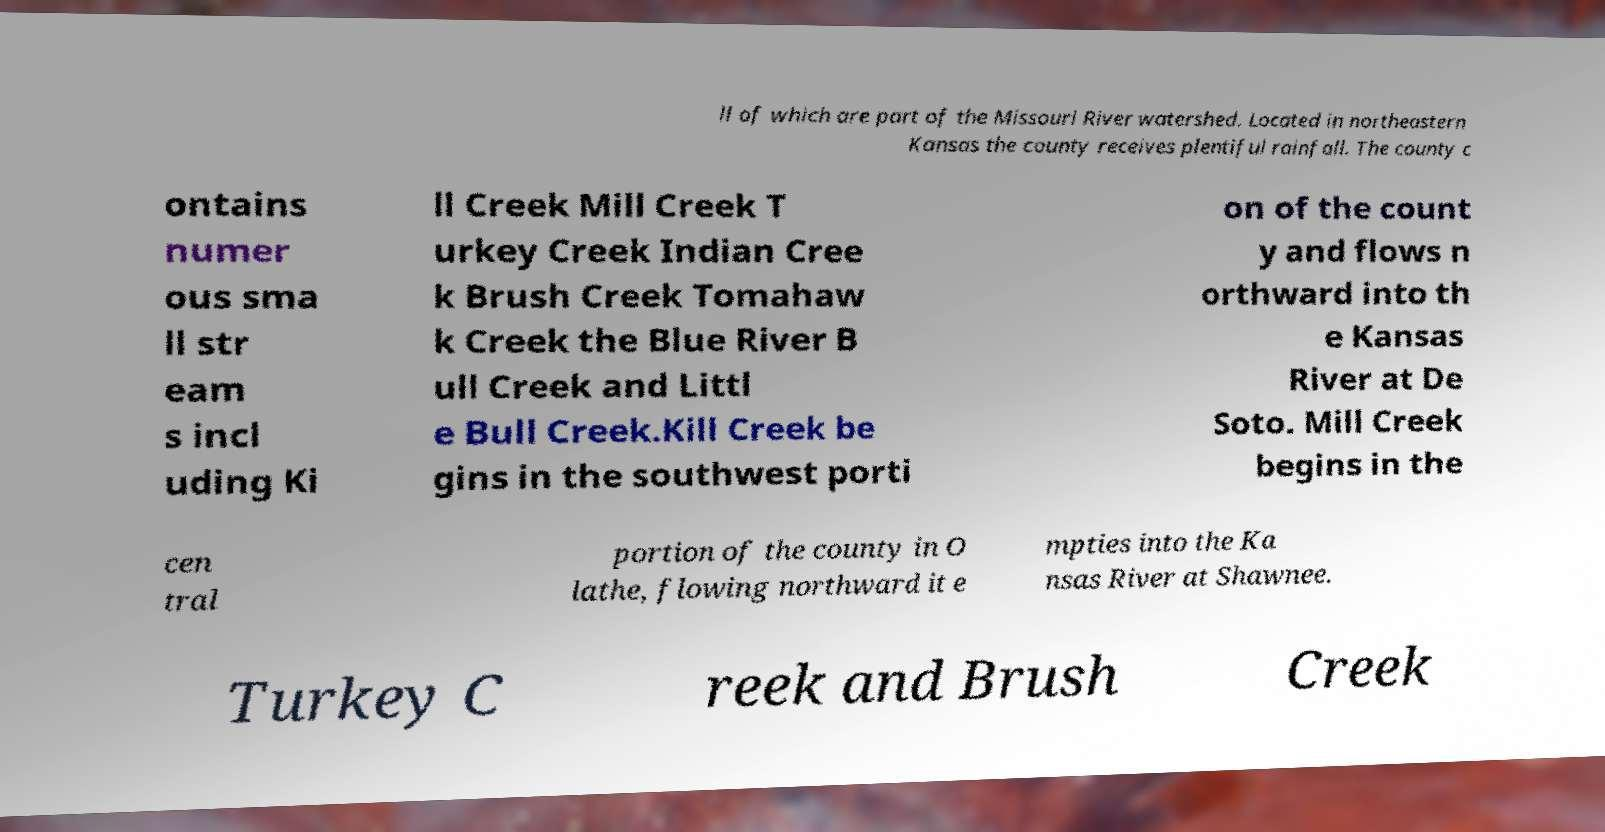There's text embedded in this image that I need extracted. Can you transcribe it verbatim? ll of which are part of the Missouri River watershed. Located in northeastern Kansas the county receives plentiful rainfall. The county c ontains numer ous sma ll str eam s incl uding Ki ll Creek Mill Creek T urkey Creek Indian Cree k Brush Creek Tomahaw k Creek the Blue River B ull Creek and Littl e Bull Creek.Kill Creek be gins in the southwest porti on of the count y and flows n orthward into th e Kansas River at De Soto. Mill Creek begins in the cen tral portion of the county in O lathe, flowing northward it e mpties into the Ka nsas River at Shawnee. Turkey C reek and Brush Creek 